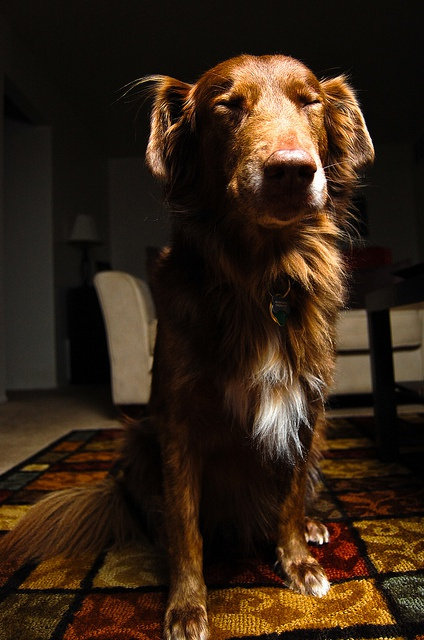Describe the objects in this image and their specific colors. I can see dog in black, maroon, and brown tones and couch in black and gray tones in this image. 